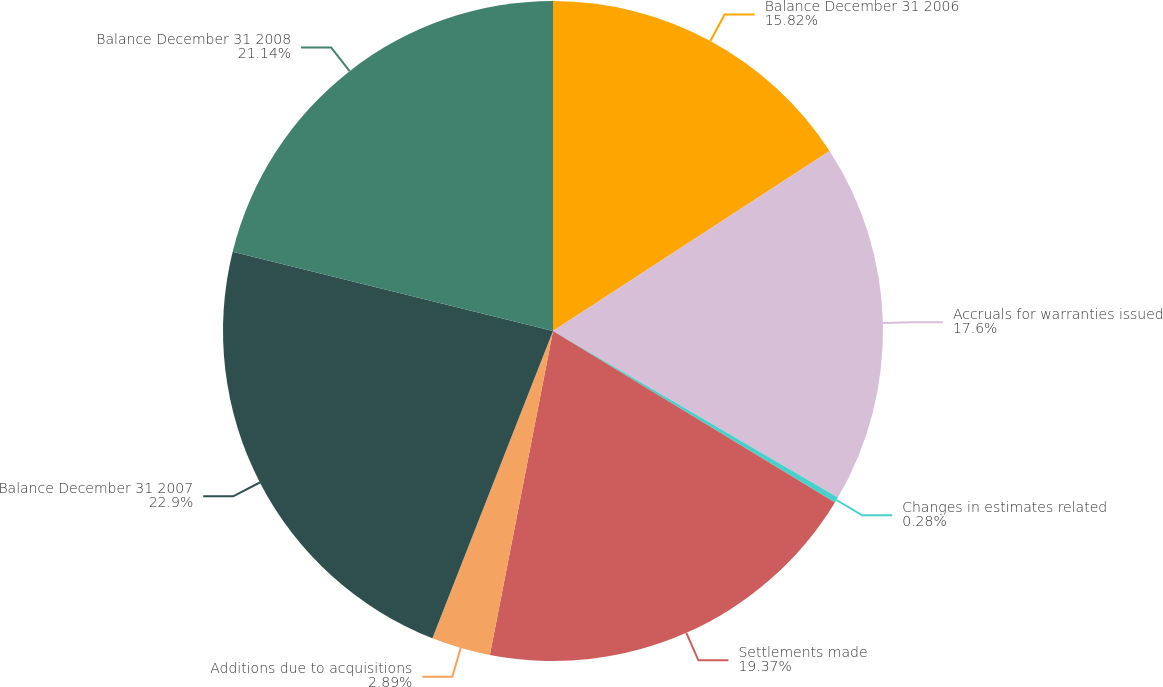<chart> <loc_0><loc_0><loc_500><loc_500><pie_chart><fcel>Balance December 31 2006<fcel>Accruals for warranties issued<fcel>Changes in estimates related<fcel>Settlements made<fcel>Additions due to acquisitions<fcel>Balance December 31 2007<fcel>Balance December 31 2008<nl><fcel>15.82%<fcel>17.6%<fcel>0.28%<fcel>19.37%<fcel>2.89%<fcel>22.91%<fcel>21.14%<nl></chart> 